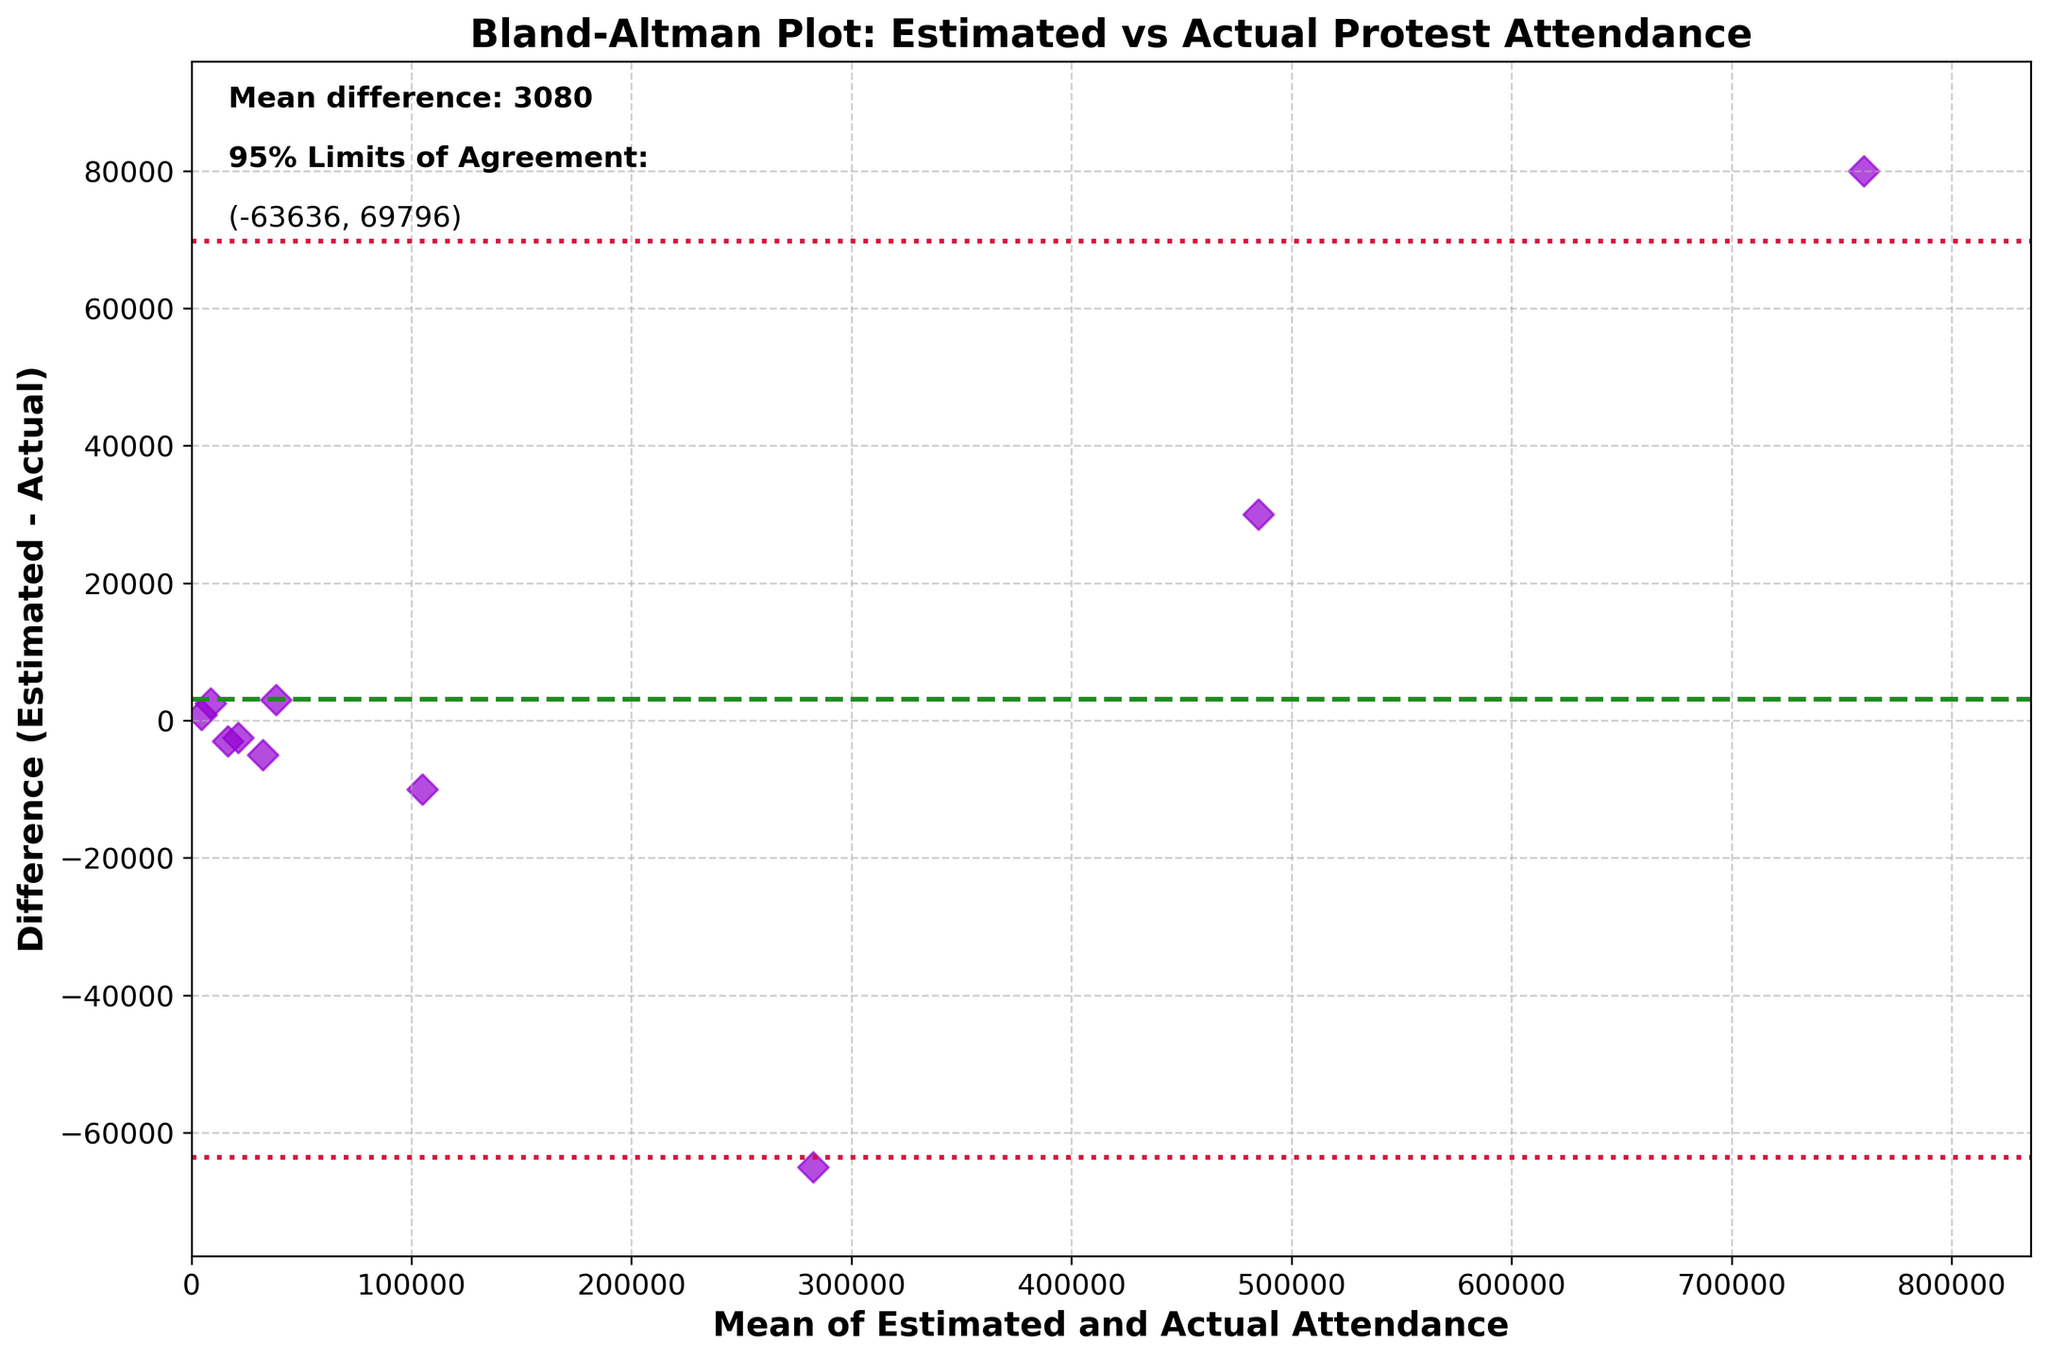What is the title of the plot? The title is usually placed at the top of the plot, and here it reads "Bland-Altman Plot: Estimated vs Actual Protest Attendance."
Answer: Bland-Altman Plot: Estimated vs Actual Protest Attendance How many data points are plotted on the graph? You can count the number of distinct markers present on the plot. Here there are 10 scattered points representing each event.
Answer: 10 What is the color of the scatter points? The color of the scatter points is indicated in the description, which here is 'darkviolet'.
Answer: darkviolet What are the axis labels of the plot? The labels for the axes are mentioned in the description. The x-axis is labeled "Mean of Estimated and Actual Attendance," and the y-axis is labeled "Difference (Estimated - Actual)."
Answer: Mean of Estimated and Actual Attendance (x-axis), Difference (Estimated - Actual) (y-axis) What does the green dashed line represent? The green dashed line represents the mean difference between the estimated and actual attendance numbers, indicated by its color 'forestgreen'.
Answer: Mean difference Between what two numbers are the limits of agreement? The limits of agreement are represented by the crimson dotted lines, identified in the description. These values are roughly calculated as 8, and -107910.
Answer: (-108308, 107910) Which event has the highest mean attendance? The highest mean attendance can be found by identifying the point farthest to the right on the x-axis. This event is the March for Our Lives 2018, with a midpoint mean attendance.
Answer: March for Our Lives 2018 Which event shows the largest positive difference between estimated and actual attendance? The largest positive difference is represented by the highest point on the y-axis. Here, it is the Climate Strike NYC 2019.
Answer: Climate Strike NYC 2019 Which event shows the largest negative difference between estimated and actual attendance? The largest negative difference is represented by the lowest point on the y-axis, which corresponds to the Women's March 2017.
Answer: Women's March 2017 Where is the point representing the Black Lives Matter DC 2020 event on the plot? You can identify the Black Lives Matter DC 2020 event by looking for the point that matches its mean attendance and difference. It has a mean attendance of 16500 and a difference of -3000.
Answer: (16500, -3000) 